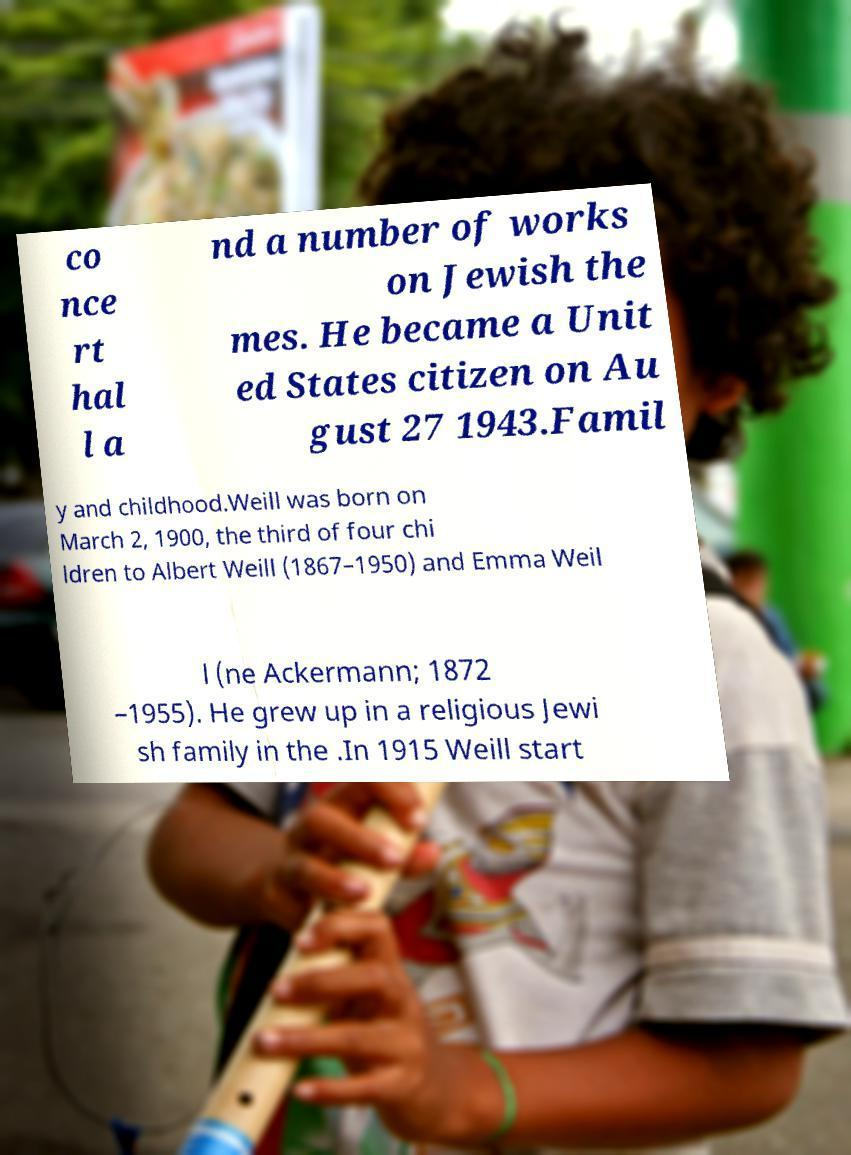There's text embedded in this image that I need extracted. Can you transcribe it verbatim? co nce rt hal l a nd a number of works on Jewish the mes. He became a Unit ed States citizen on Au gust 27 1943.Famil y and childhood.Weill was born on March 2, 1900, the third of four chi ldren to Albert Weill (1867–1950) and Emma Weil l (ne Ackermann; 1872 –1955). He grew up in a religious Jewi sh family in the .In 1915 Weill start 